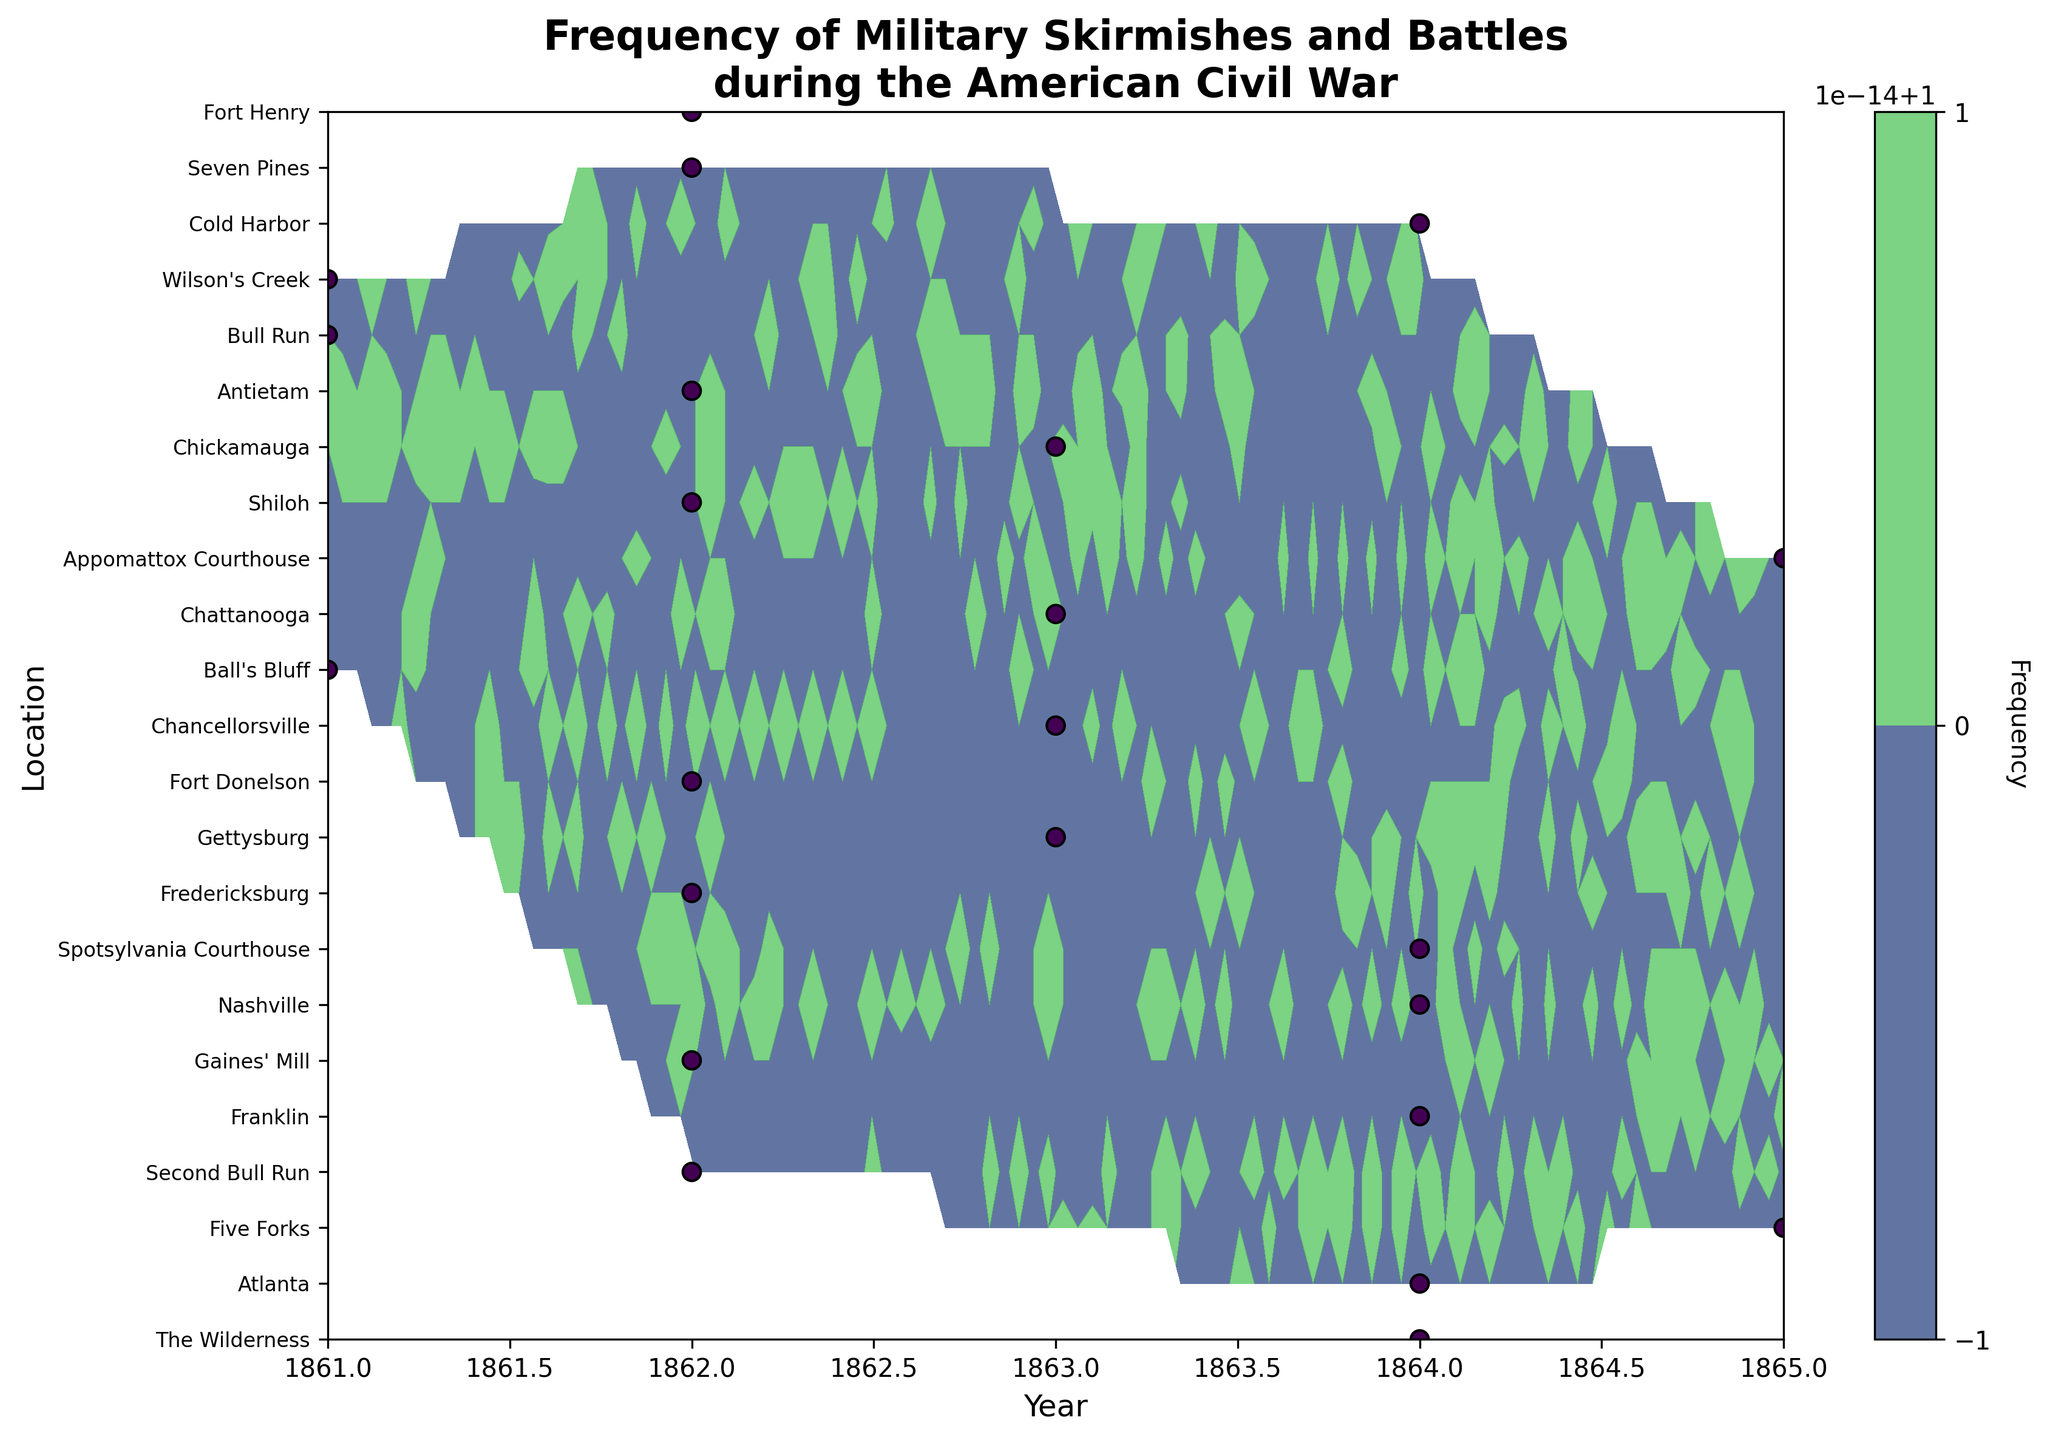What is the title of the figure? The title is usually located at the top of the figure. It summarizes the topic or the main idea of the plot.
Answer: Frequency of Military Skirmishes and Battles during the American Civil War Which year saw the highest concentration of battles according to the contour plot? To identify the highest concentration of battles, look for the region on the plot with the darkest color, indicating the highest frequency.
Answer: 1864 How many unique locations are mentioned in the plot? The y-axis represents the unique locations. Count the number of distinct y-ticks to get the answer.
Answer: 23 What's the frequency of battles at Gettysburg in 1863? Locate the point corresponding to Gettysburg on the y-axis and 1863 on the x-axis. Check the color intensity and data point to determine the frequency.
Answer: 1 How does the frequency of battles in 1861 compare to that in 1862? Check the contour levels and colors for both years. If a year has more intense and frequent colors, it has more battles.
Answer: 1862 had more frequent battles than 1861 What can you infer about the trend of skirmishes from 1861 to 1865? Observe the color gradient from 1861 to 1865. Darker regions indicate higher frequencies, showing the trend over the years.
Answer: The frequency of battles generally increased, peaking around 1864, then declined in 1865 Which location had battles in every year from 1861 to 1865? Identify if any horizontal line (location) shows points or color intensity across all years from 1861 to 1865.
Answer: There is no single location with battles every year from 1861 to 1865 How do battles at Bull Run in 1861 compare visually to those at Antietam in 1862? Locate Bull Run in 1861 and Antietam in 1862. Compare the contour levels and colors to determine which had more intense frequency.
Answer: Both have the same frequency, as indicated by their color and single occurrence 